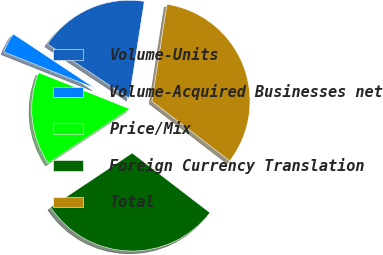Convert chart to OTSL. <chart><loc_0><loc_0><loc_500><loc_500><pie_chart><fcel>Volume-Units<fcel>Volume-Acquired Businesses net<fcel>Price/Mix<fcel>Foreign Currency Translation<fcel>Total<nl><fcel>18.13%<fcel>3.3%<fcel>15.38%<fcel>30.22%<fcel>32.97%<nl></chart> 